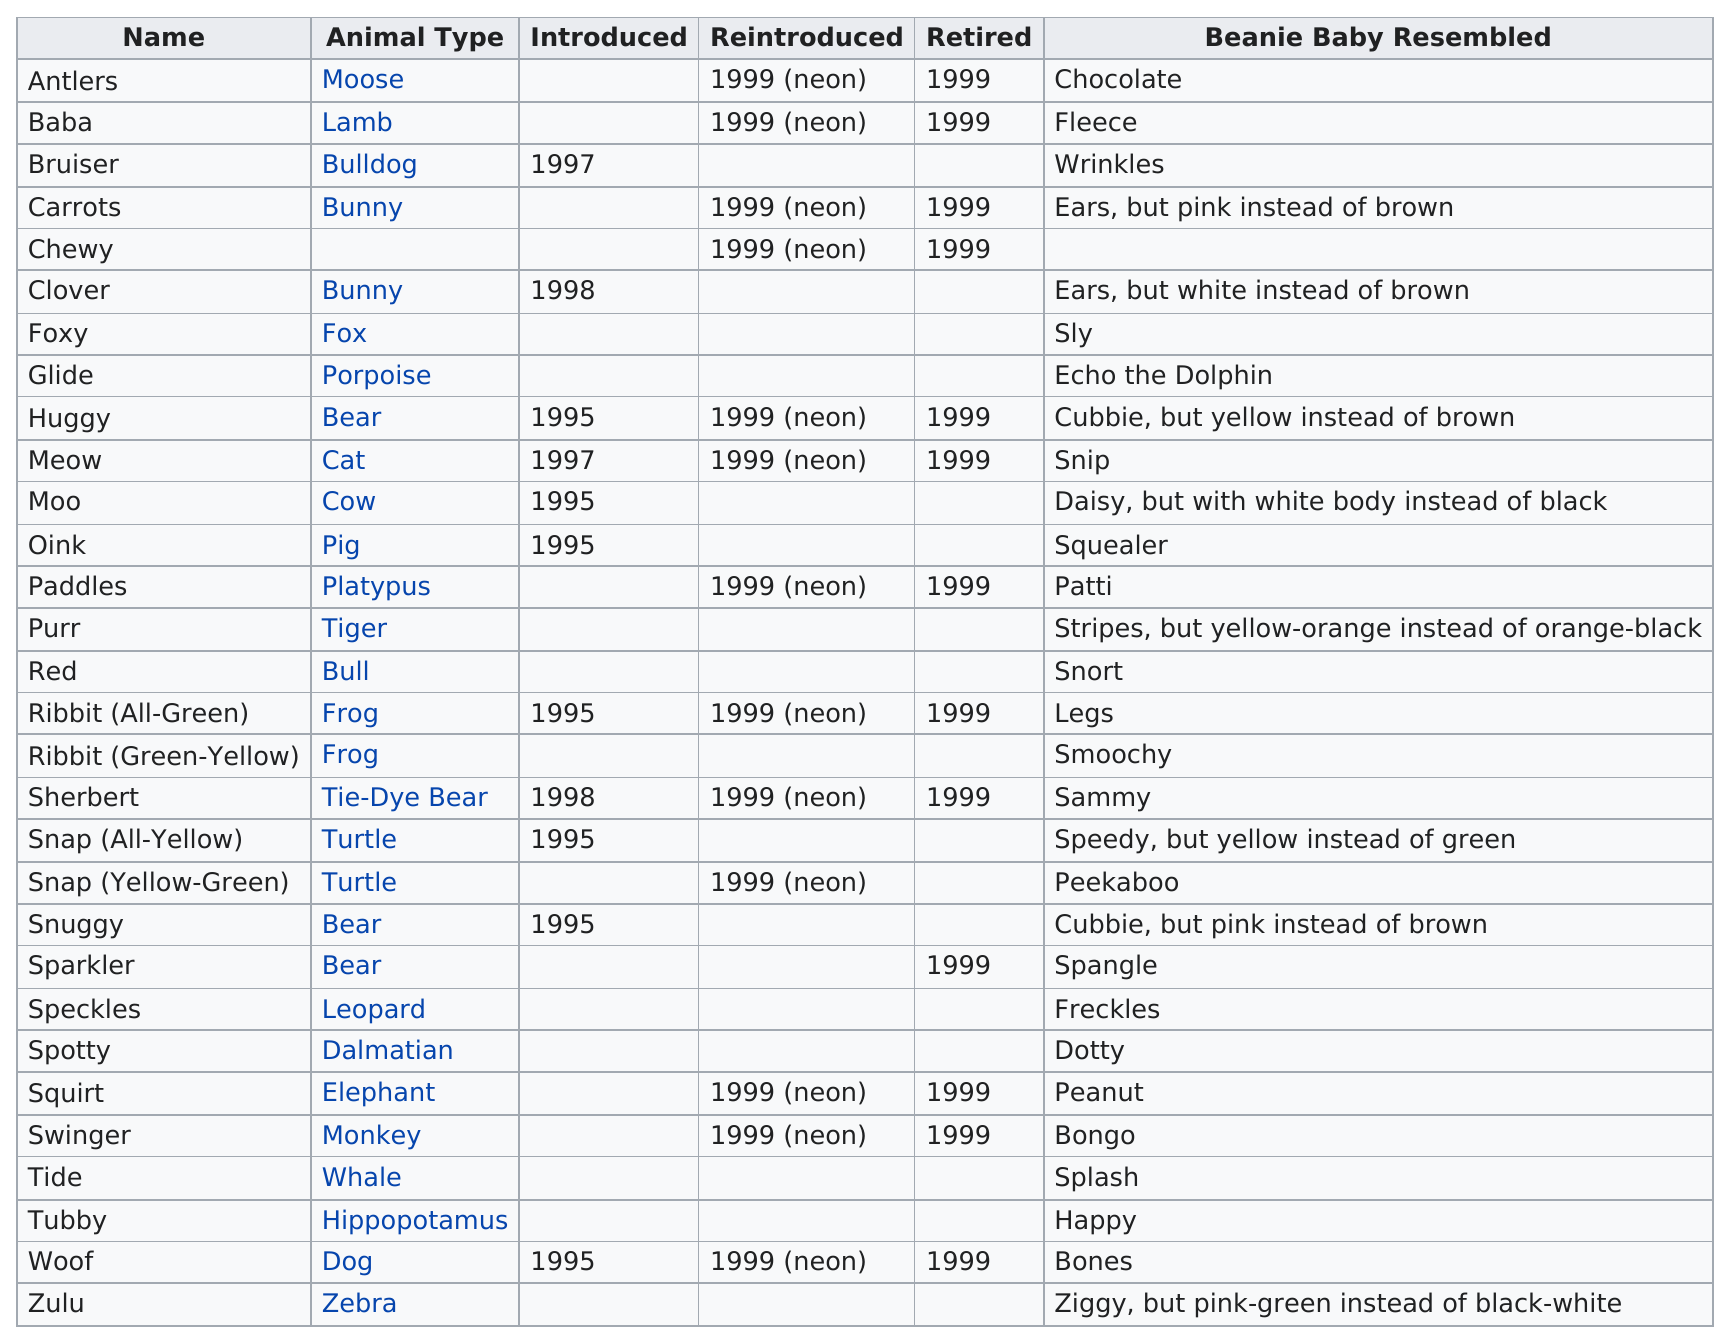List a handful of essential elements in this visual. A total of 13 neon pillow pals were reintroduced after being previously available. In 1999, a total of 13 pillow pals were reintroduced. There were 1 monkey pillow pal. Woof the dog was sold for a total of four years before it was retired. It is notable that Chewy is the only pillow pal without an indicated animal type, as indicated by its listing. 